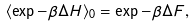<formula> <loc_0><loc_0><loc_500><loc_500>\langle \exp - \beta \Delta H \rangle _ { 0 } = \exp - \beta \Delta F ,</formula> 